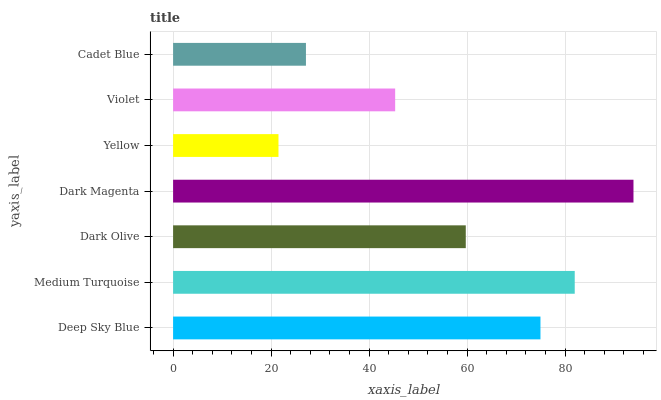Is Yellow the minimum?
Answer yes or no. Yes. Is Dark Magenta the maximum?
Answer yes or no. Yes. Is Medium Turquoise the minimum?
Answer yes or no. No. Is Medium Turquoise the maximum?
Answer yes or no. No. Is Medium Turquoise greater than Deep Sky Blue?
Answer yes or no. Yes. Is Deep Sky Blue less than Medium Turquoise?
Answer yes or no. Yes. Is Deep Sky Blue greater than Medium Turquoise?
Answer yes or no. No. Is Medium Turquoise less than Deep Sky Blue?
Answer yes or no. No. Is Dark Olive the high median?
Answer yes or no. Yes. Is Dark Olive the low median?
Answer yes or no. Yes. Is Deep Sky Blue the high median?
Answer yes or no. No. Is Cadet Blue the low median?
Answer yes or no. No. 